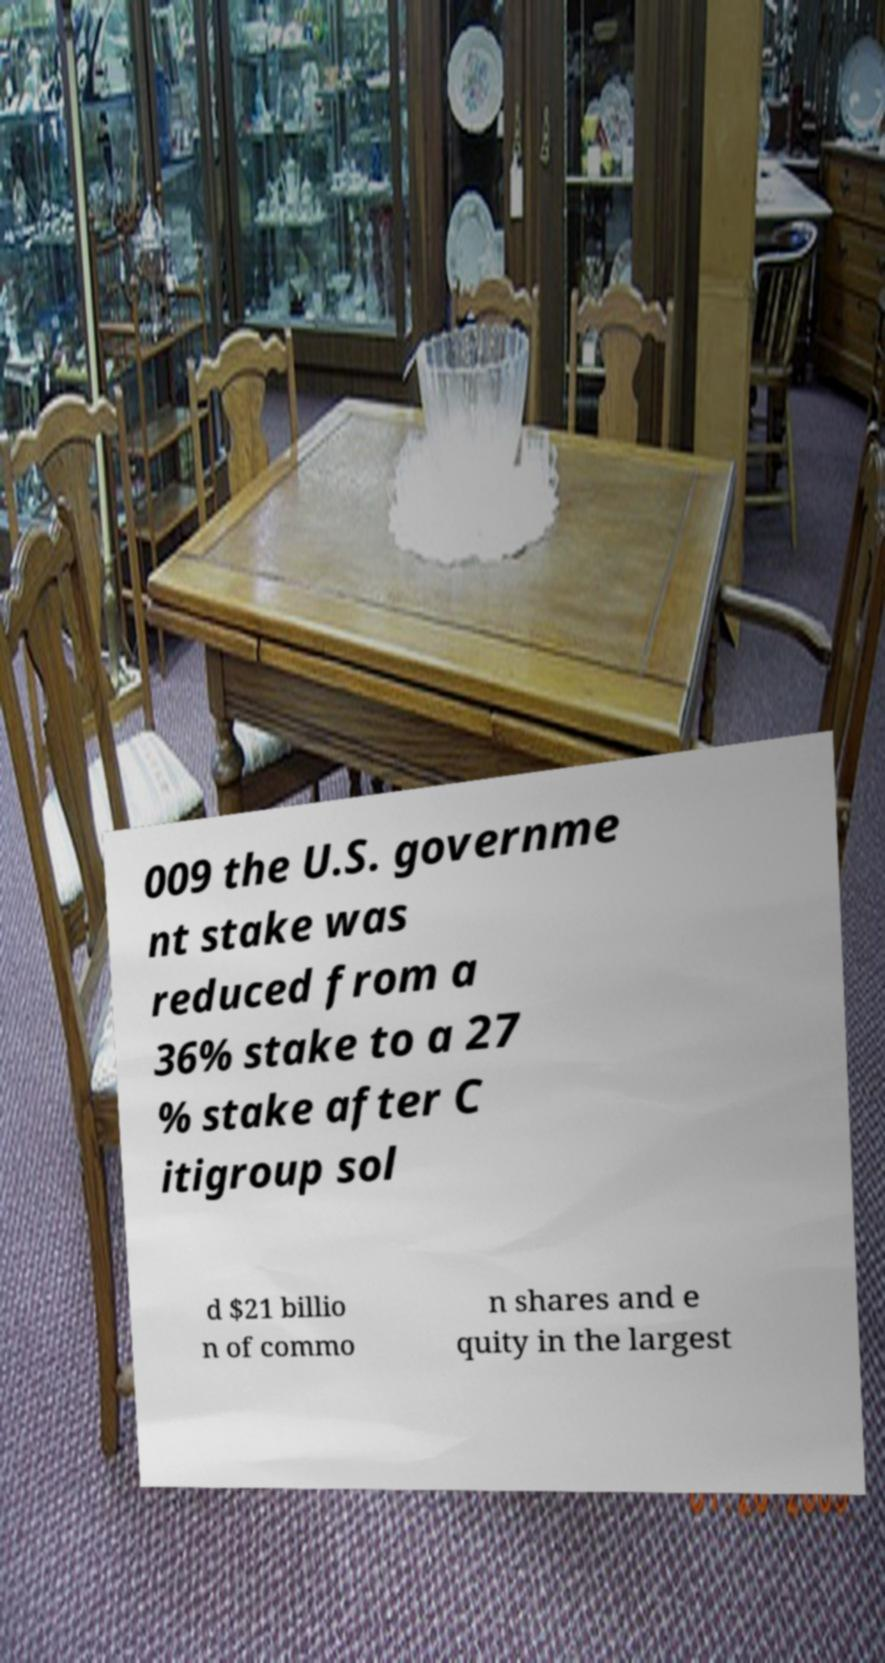Could you assist in decoding the text presented in this image and type it out clearly? 009 the U.S. governme nt stake was reduced from a 36% stake to a 27 % stake after C itigroup sol d $21 billio n of commo n shares and e quity in the largest 